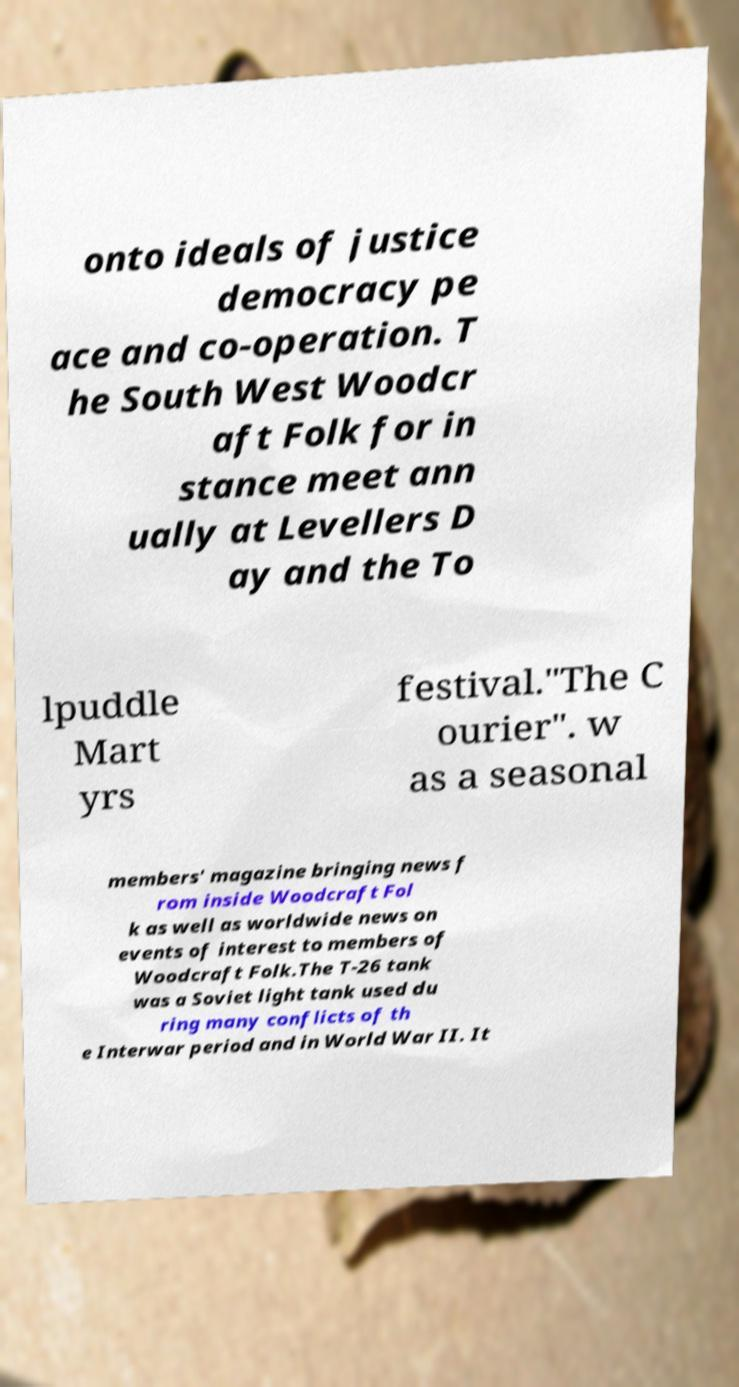Could you assist in decoding the text presented in this image and type it out clearly? onto ideals of justice democracy pe ace and co-operation. T he South West Woodcr aft Folk for in stance meet ann ually at Levellers D ay and the To lpuddle Mart yrs festival."The C ourier". w as a seasonal members' magazine bringing news f rom inside Woodcraft Fol k as well as worldwide news on events of interest to members of Woodcraft Folk.The T-26 tank was a Soviet light tank used du ring many conflicts of th e Interwar period and in World War II. It 